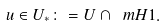<formula> <loc_0><loc_0><loc_500><loc_500>u \in U _ { * } \colon = U \cap \ m { H 1 } .</formula> 